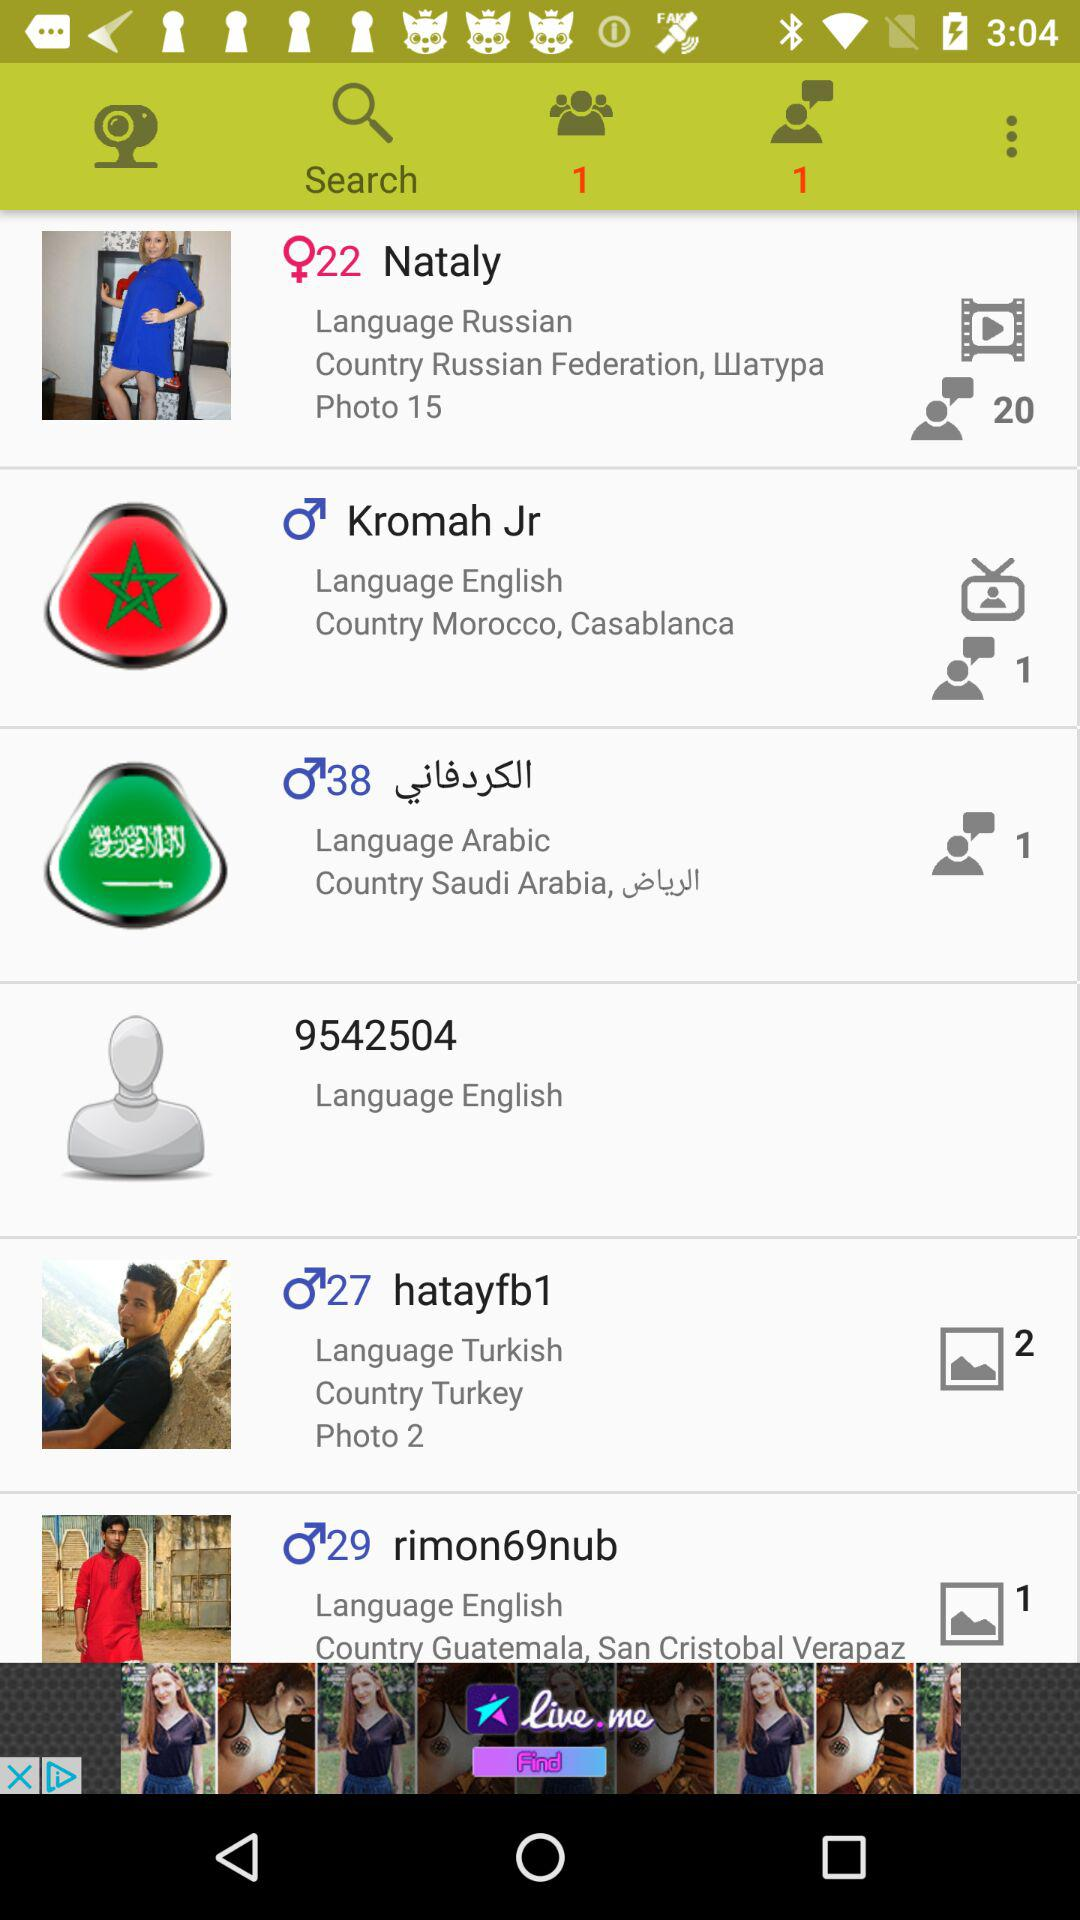Where is "hatayfb1" from? "hatayfb1" is from Turkey. 